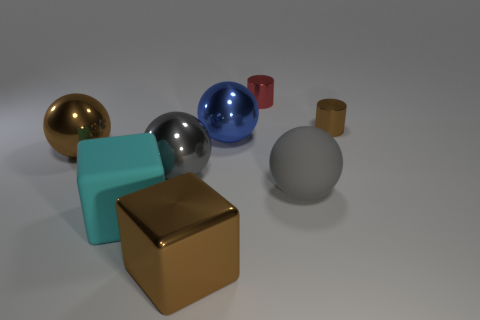Add 1 small brown metal balls. How many objects exist? 9 Subtract all blocks. How many objects are left? 6 Add 3 blue shiny balls. How many blue shiny balls are left? 4 Add 5 blue spheres. How many blue spheres exist? 6 Subtract 0 cyan cylinders. How many objects are left? 8 Subtract all large cyan rubber things. Subtract all big blue shiny objects. How many objects are left? 6 